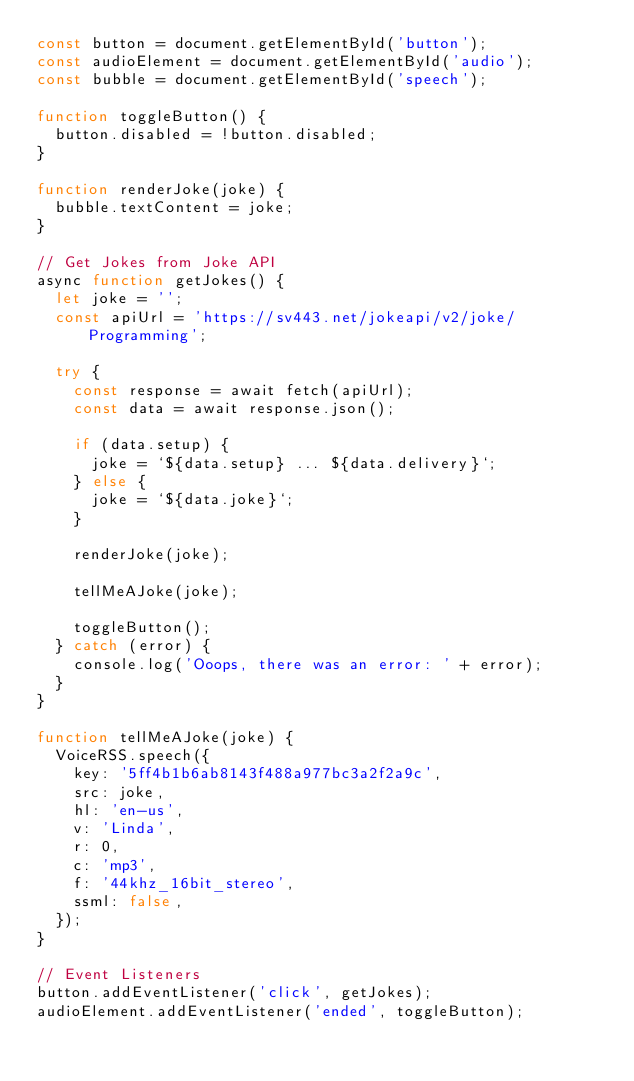Convert code to text. <code><loc_0><loc_0><loc_500><loc_500><_JavaScript_>const button = document.getElementById('button');
const audioElement = document.getElementById('audio');
const bubble = document.getElementById('speech');

function toggleButton() {
  button.disabled = !button.disabled;
}

function renderJoke(joke) {
  bubble.textContent = joke;
}

// Get Jokes from Joke API
async function getJokes() {
  let joke = '';
  const apiUrl = 'https://sv443.net/jokeapi/v2/joke/Programming';

  try {
    const response = await fetch(apiUrl);
    const data = await response.json();

    if (data.setup) {
      joke = `${data.setup} ... ${data.delivery}`;
    } else {
      joke = `${data.joke}`;
    }

    renderJoke(joke);

    tellMeAJoke(joke);

    toggleButton();
  } catch (error) {
    console.log('Ooops, there was an error: ' + error);
  }
}

function tellMeAJoke(joke) {
  VoiceRSS.speech({
    key: '5ff4b1b6ab8143f488a977bc3a2f2a9c',
    src: joke,
    hl: 'en-us',
    v: 'Linda',
    r: 0,
    c: 'mp3',
    f: '44khz_16bit_stereo',
    ssml: false,
  });
}

// Event Listeners
button.addEventListener('click', getJokes);
audioElement.addEventListener('ended', toggleButton);
</code> 